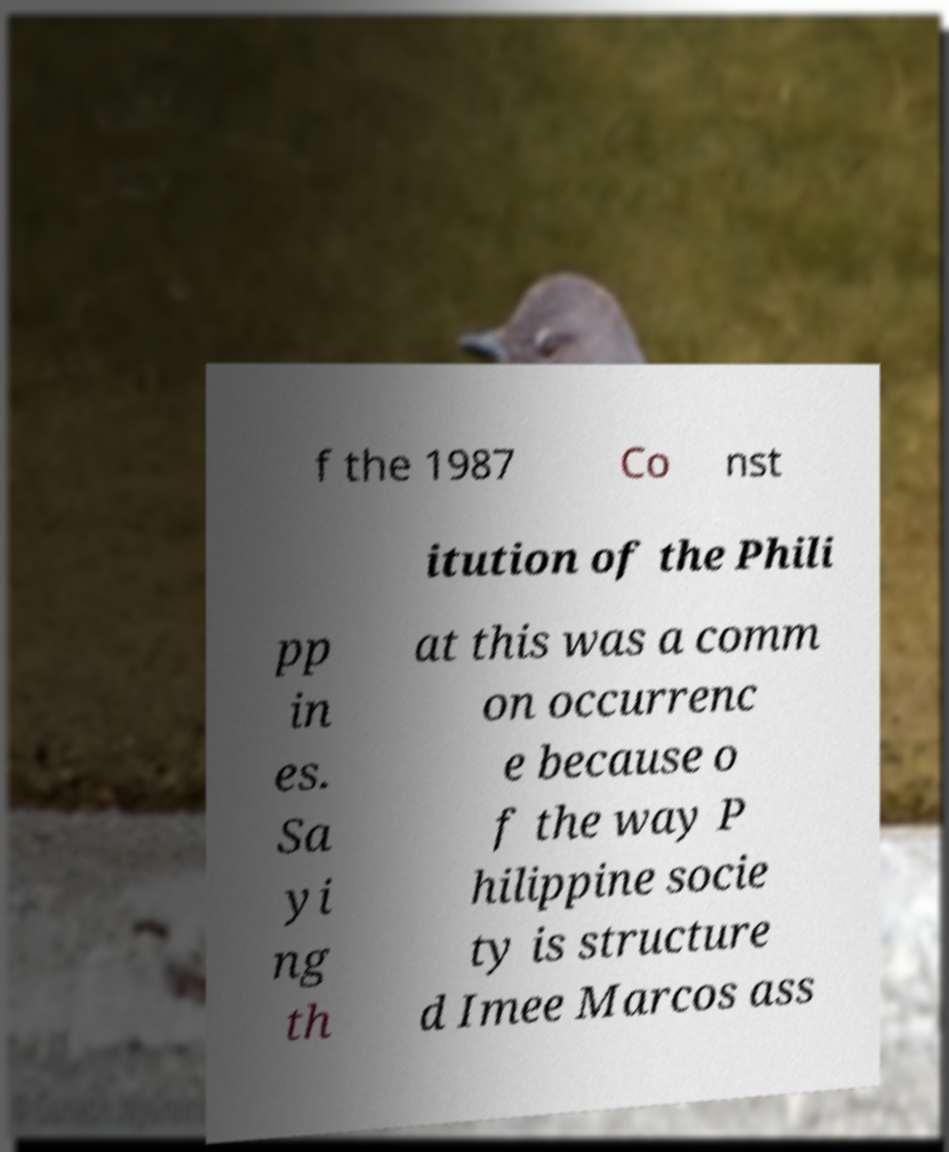What messages or text are displayed in this image? I need them in a readable, typed format. f the 1987 Co nst itution of the Phili pp in es. Sa yi ng th at this was a comm on occurrenc e because o f the way P hilippine socie ty is structure d Imee Marcos ass 